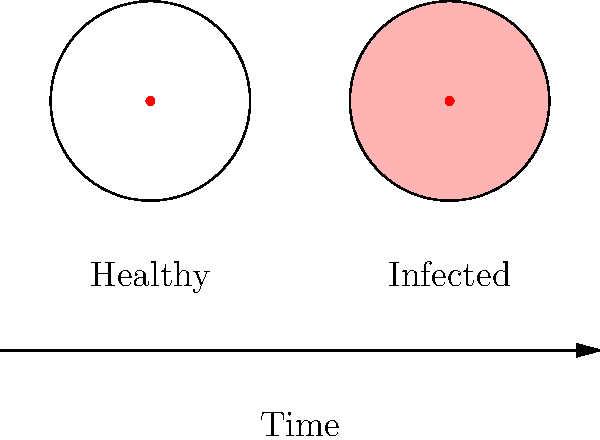In the image comparing healthy and infected oral piercing sites, what is the primary visual indicator of infection? To identify the primary visual indicator of infection in oral piercings, let's analyze the image step-by-step:

1. The image shows two circular representations of piercing sites: one labeled "Healthy" and the other labeled "Infected".

2. Both circles have a red dot in the center, representing the actual piercing.

3. The main difference between the two is the color of the surrounding area:
   a. The healthy piercing site has a white surrounding area.
   b. The infected piercing site has a light pink or reddish surrounding area.

4. This color change in the infected site represents inflammation, which is a common sign of infection.

5. Inflammation causes increased blood flow to the affected area, resulting in redness, swelling, and warmth.

6. In oral piercings, this redness or pink coloration around the piercing site is often one of the earliest and most noticeable signs of infection.

Therefore, the primary visual indicator of infection in this image is the redness or pink coloration surrounding the piercing site.
Answer: Redness surrounding the piercing site 